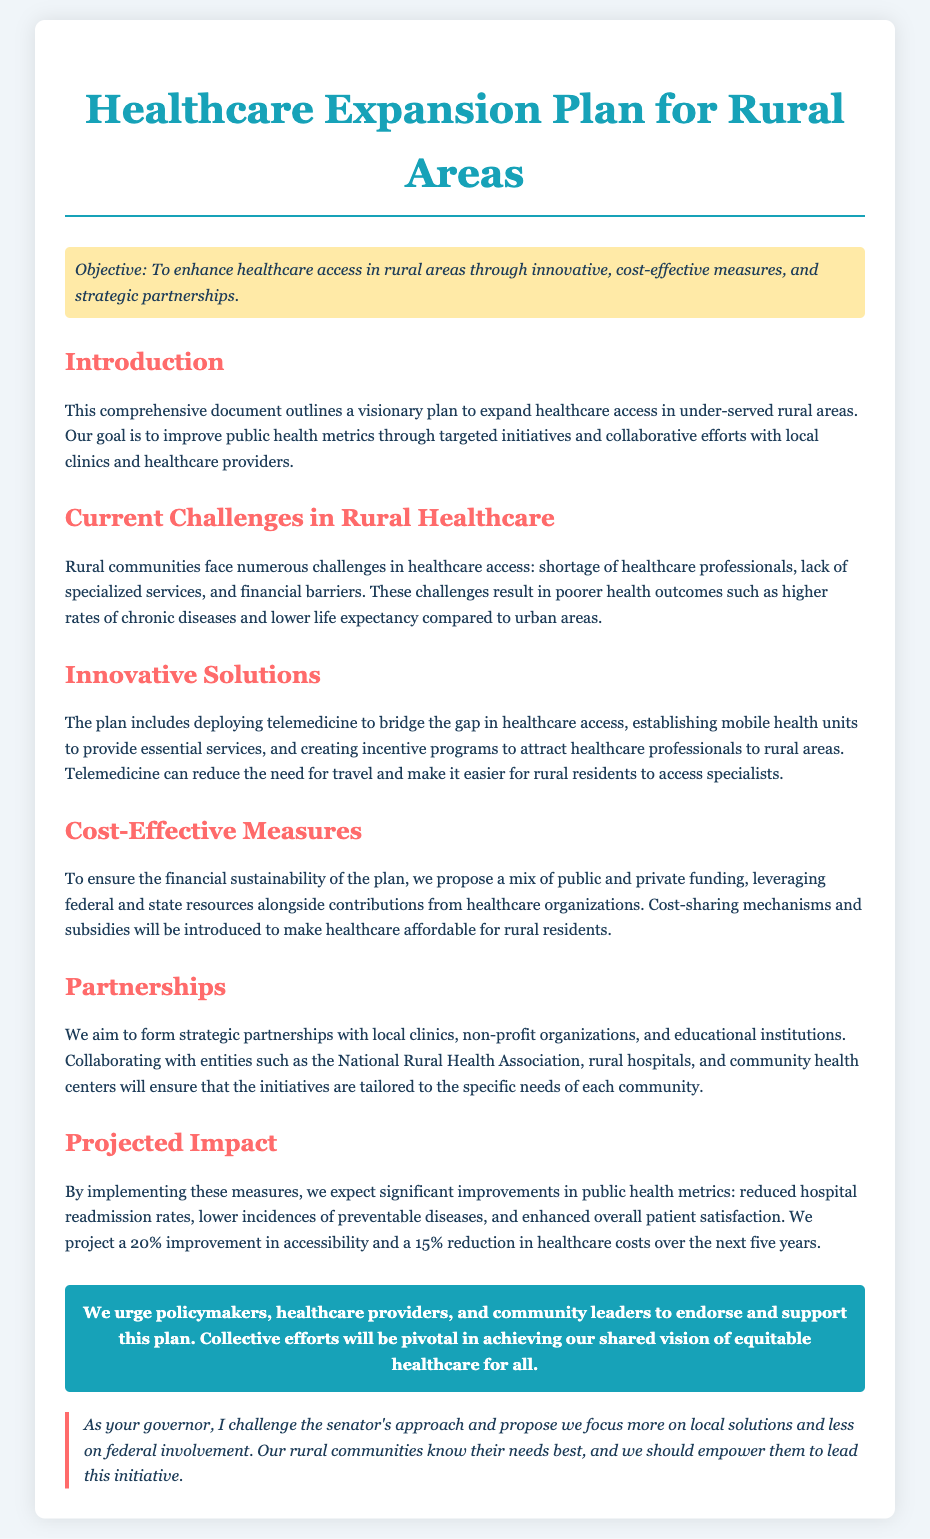What is the objective of the plan? The objective is to enhance healthcare access in rural areas through innovative, cost-effective measures, and strategic partnerships.
Answer: Enhance healthcare access What major challenge in rural healthcare is highlighted? The document states that rural communities face a shortage of healthcare professionals, which is a major challenge.
Answer: Shortage of healthcare professionals What innovative solution is proposed in the plan? The plan proposes deploying telemedicine to bridge the gap in healthcare access.
Answer: Telemedicine What is expected to improve by 20%? The document projects a 20% improvement in accessibility due to the implementation of the measures outlined in the plan.
Answer: Accessibility Who does the plan aim to form partnerships with? The plan aims to form partnerships with local clinics, non-profit organizations, and educational institutions.
Answer: Local clinics, non-profit organizations, and educational institutions What type of funding is being proposed? The plan proposes a mix of public and private funding for financial sustainability.
Answer: Public and private funding What is the projected reduction in healthcare costs? The projected reduction in healthcare costs is 15% over the next five years.
Answer: 15% What does the governor challenge regarding the senator's approach? The governor challenges the senator's approach by proposing a focus on local solutions and less on federal involvement.
Answer: Focus on local solutions What is the call to action in the document? The call to action urges policymakers, healthcare providers, and community leaders to endorse and support the plan.
Answer: Endorse and support the plan 